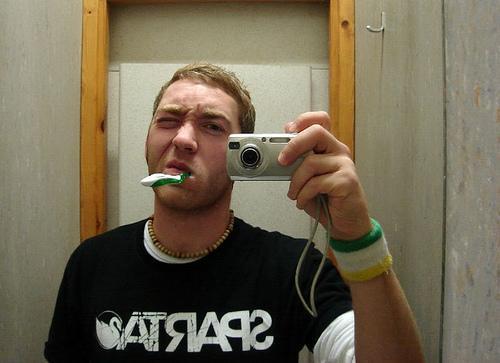How many girls are pictured?
Give a very brief answer. 0. 